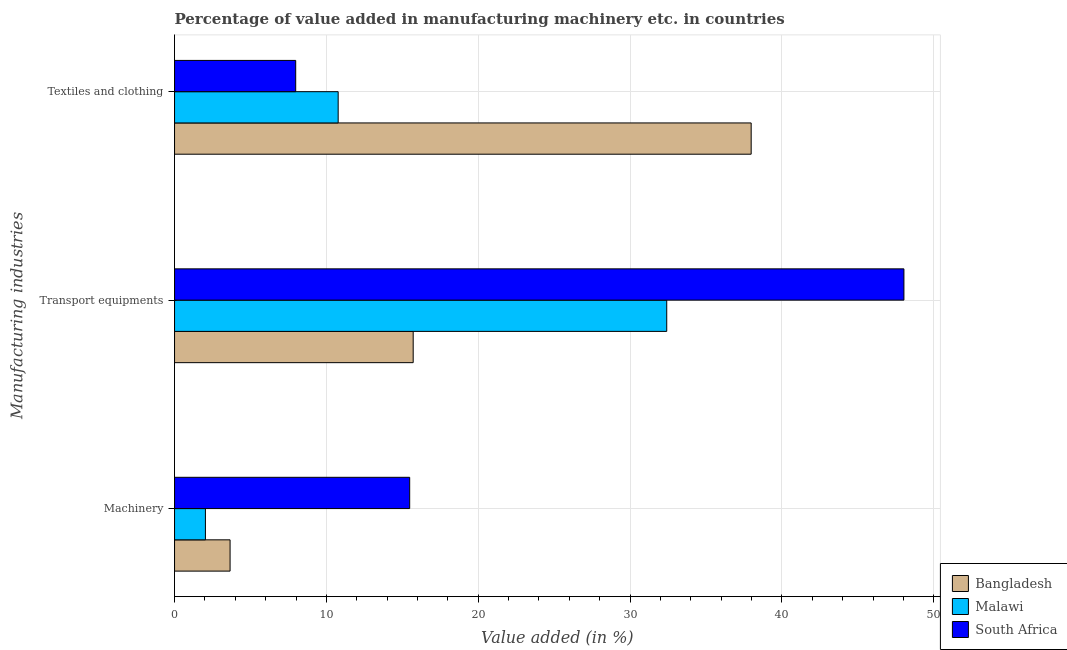Are the number of bars per tick equal to the number of legend labels?
Give a very brief answer. Yes. Are the number of bars on each tick of the Y-axis equal?
Keep it short and to the point. Yes. How many bars are there on the 3rd tick from the top?
Your answer should be compact. 3. How many bars are there on the 2nd tick from the bottom?
Your answer should be very brief. 3. What is the label of the 3rd group of bars from the top?
Your response must be concise. Machinery. What is the value added in manufacturing transport equipments in South Africa?
Make the answer very short. 48.04. Across all countries, what is the maximum value added in manufacturing machinery?
Your answer should be compact. 15.49. Across all countries, what is the minimum value added in manufacturing transport equipments?
Your answer should be compact. 15.72. In which country was the value added in manufacturing machinery maximum?
Your answer should be compact. South Africa. What is the total value added in manufacturing transport equipments in the graph?
Your answer should be compact. 96.17. What is the difference between the value added in manufacturing transport equipments in South Africa and that in Bangladesh?
Give a very brief answer. 32.32. What is the difference between the value added in manufacturing machinery in South Africa and the value added in manufacturing textile and clothing in Bangladesh?
Provide a succinct answer. -22.49. What is the average value added in manufacturing textile and clothing per country?
Make the answer very short. 18.91. What is the difference between the value added in manufacturing transport equipments and value added in manufacturing textile and clothing in Malawi?
Your response must be concise. 21.64. What is the ratio of the value added in manufacturing transport equipments in South Africa to that in Malawi?
Your answer should be compact. 1.48. Is the value added in manufacturing transport equipments in Bangladesh less than that in Malawi?
Make the answer very short. Yes. Is the difference between the value added in manufacturing machinery in Bangladesh and Malawi greater than the difference between the value added in manufacturing textile and clothing in Bangladesh and Malawi?
Give a very brief answer. No. What is the difference between the highest and the second highest value added in manufacturing machinery?
Ensure brevity in your answer.  11.83. What is the difference between the highest and the lowest value added in manufacturing transport equipments?
Provide a short and direct response. 32.32. Is the sum of the value added in manufacturing textile and clothing in South Africa and Malawi greater than the maximum value added in manufacturing transport equipments across all countries?
Ensure brevity in your answer.  No. What does the 1st bar from the top in Textiles and clothing represents?
Offer a very short reply. South Africa. What does the 2nd bar from the bottom in Textiles and clothing represents?
Offer a terse response. Malawi. Is it the case that in every country, the sum of the value added in manufacturing machinery and value added in manufacturing transport equipments is greater than the value added in manufacturing textile and clothing?
Provide a succinct answer. No. Are all the bars in the graph horizontal?
Keep it short and to the point. Yes. What is the difference between two consecutive major ticks on the X-axis?
Make the answer very short. 10. Are the values on the major ticks of X-axis written in scientific E-notation?
Provide a succinct answer. No. Does the graph contain any zero values?
Give a very brief answer. No. Does the graph contain grids?
Make the answer very short. Yes. Where does the legend appear in the graph?
Provide a short and direct response. Bottom right. How are the legend labels stacked?
Your answer should be compact. Vertical. What is the title of the graph?
Your answer should be compact. Percentage of value added in manufacturing machinery etc. in countries. Does "Algeria" appear as one of the legend labels in the graph?
Your answer should be compact. No. What is the label or title of the X-axis?
Make the answer very short. Value added (in %). What is the label or title of the Y-axis?
Ensure brevity in your answer.  Manufacturing industries. What is the Value added (in %) of Bangladesh in Machinery?
Offer a terse response. 3.66. What is the Value added (in %) of Malawi in Machinery?
Offer a terse response. 2.03. What is the Value added (in %) of South Africa in Machinery?
Ensure brevity in your answer.  15.49. What is the Value added (in %) in Bangladesh in Transport equipments?
Offer a very short reply. 15.72. What is the Value added (in %) of Malawi in Transport equipments?
Offer a very short reply. 32.42. What is the Value added (in %) of South Africa in Transport equipments?
Your answer should be very brief. 48.04. What is the Value added (in %) in Bangladesh in Textiles and clothing?
Keep it short and to the point. 37.98. What is the Value added (in %) of Malawi in Textiles and clothing?
Your response must be concise. 10.78. What is the Value added (in %) of South Africa in Textiles and clothing?
Make the answer very short. 7.98. Across all Manufacturing industries, what is the maximum Value added (in %) in Bangladesh?
Offer a terse response. 37.98. Across all Manufacturing industries, what is the maximum Value added (in %) in Malawi?
Your answer should be compact. 32.42. Across all Manufacturing industries, what is the maximum Value added (in %) of South Africa?
Your answer should be very brief. 48.04. Across all Manufacturing industries, what is the minimum Value added (in %) of Bangladesh?
Keep it short and to the point. 3.66. Across all Manufacturing industries, what is the minimum Value added (in %) in Malawi?
Provide a succinct answer. 2.03. Across all Manufacturing industries, what is the minimum Value added (in %) of South Africa?
Keep it short and to the point. 7.98. What is the total Value added (in %) of Bangladesh in the graph?
Offer a very short reply. 57.35. What is the total Value added (in %) in Malawi in the graph?
Give a very brief answer. 45.22. What is the total Value added (in %) in South Africa in the graph?
Keep it short and to the point. 71.5. What is the difference between the Value added (in %) in Bangladesh in Machinery and that in Transport equipments?
Provide a succinct answer. -12.06. What is the difference between the Value added (in %) of Malawi in Machinery and that in Transport equipments?
Offer a terse response. -30.38. What is the difference between the Value added (in %) of South Africa in Machinery and that in Transport equipments?
Ensure brevity in your answer.  -32.55. What is the difference between the Value added (in %) in Bangladesh in Machinery and that in Textiles and clothing?
Give a very brief answer. -34.32. What is the difference between the Value added (in %) in Malawi in Machinery and that in Textiles and clothing?
Make the answer very short. -8.74. What is the difference between the Value added (in %) in South Africa in Machinery and that in Textiles and clothing?
Your answer should be very brief. 7.51. What is the difference between the Value added (in %) of Bangladesh in Transport equipments and that in Textiles and clothing?
Provide a short and direct response. -22.26. What is the difference between the Value added (in %) in Malawi in Transport equipments and that in Textiles and clothing?
Provide a succinct answer. 21.64. What is the difference between the Value added (in %) of South Africa in Transport equipments and that in Textiles and clothing?
Your answer should be very brief. 40.06. What is the difference between the Value added (in %) of Bangladesh in Machinery and the Value added (in %) of Malawi in Transport equipments?
Your answer should be very brief. -28.76. What is the difference between the Value added (in %) of Bangladesh in Machinery and the Value added (in %) of South Africa in Transport equipments?
Your answer should be very brief. -44.38. What is the difference between the Value added (in %) of Malawi in Machinery and the Value added (in %) of South Africa in Transport equipments?
Offer a terse response. -46. What is the difference between the Value added (in %) of Bangladesh in Machinery and the Value added (in %) of Malawi in Textiles and clothing?
Offer a terse response. -7.12. What is the difference between the Value added (in %) of Bangladesh in Machinery and the Value added (in %) of South Africa in Textiles and clothing?
Make the answer very short. -4.32. What is the difference between the Value added (in %) in Malawi in Machinery and the Value added (in %) in South Africa in Textiles and clothing?
Your answer should be very brief. -5.95. What is the difference between the Value added (in %) in Bangladesh in Transport equipments and the Value added (in %) in Malawi in Textiles and clothing?
Offer a very short reply. 4.94. What is the difference between the Value added (in %) of Bangladesh in Transport equipments and the Value added (in %) of South Africa in Textiles and clothing?
Make the answer very short. 7.74. What is the difference between the Value added (in %) in Malawi in Transport equipments and the Value added (in %) in South Africa in Textiles and clothing?
Make the answer very short. 24.44. What is the average Value added (in %) of Bangladesh per Manufacturing industries?
Provide a succinct answer. 19.12. What is the average Value added (in %) in Malawi per Manufacturing industries?
Your answer should be very brief. 15.07. What is the average Value added (in %) in South Africa per Manufacturing industries?
Provide a short and direct response. 23.83. What is the difference between the Value added (in %) of Bangladesh and Value added (in %) of Malawi in Machinery?
Give a very brief answer. 1.62. What is the difference between the Value added (in %) of Bangladesh and Value added (in %) of South Africa in Machinery?
Make the answer very short. -11.83. What is the difference between the Value added (in %) of Malawi and Value added (in %) of South Africa in Machinery?
Your response must be concise. -13.45. What is the difference between the Value added (in %) in Bangladesh and Value added (in %) in Malawi in Transport equipments?
Ensure brevity in your answer.  -16.7. What is the difference between the Value added (in %) of Bangladesh and Value added (in %) of South Africa in Transport equipments?
Give a very brief answer. -32.32. What is the difference between the Value added (in %) of Malawi and Value added (in %) of South Africa in Transport equipments?
Your response must be concise. -15.62. What is the difference between the Value added (in %) of Bangladesh and Value added (in %) of Malawi in Textiles and clothing?
Provide a succinct answer. 27.2. What is the difference between the Value added (in %) of Bangladesh and Value added (in %) of South Africa in Textiles and clothing?
Your answer should be compact. 30. What is the difference between the Value added (in %) of Malawi and Value added (in %) of South Africa in Textiles and clothing?
Provide a short and direct response. 2.8. What is the ratio of the Value added (in %) in Bangladesh in Machinery to that in Transport equipments?
Keep it short and to the point. 0.23. What is the ratio of the Value added (in %) of Malawi in Machinery to that in Transport equipments?
Ensure brevity in your answer.  0.06. What is the ratio of the Value added (in %) in South Africa in Machinery to that in Transport equipments?
Provide a short and direct response. 0.32. What is the ratio of the Value added (in %) of Bangladesh in Machinery to that in Textiles and clothing?
Your answer should be compact. 0.1. What is the ratio of the Value added (in %) of Malawi in Machinery to that in Textiles and clothing?
Ensure brevity in your answer.  0.19. What is the ratio of the Value added (in %) in South Africa in Machinery to that in Textiles and clothing?
Provide a short and direct response. 1.94. What is the ratio of the Value added (in %) of Bangladesh in Transport equipments to that in Textiles and clothing?
Offer a terse response. 0.41. What is the ratio of the Value added (in %) of Malawi in Transport equipments to that in Textiles and clothing?
Your response must be concise. 3.01. What is the ratio of the Value added (in %) in South Africa in Transport equipments to that in Textiles and clothing?
Your answer should be very brief. 6.02. What is the difference between the highest and the second highest Value added (in %) of Bangladesh?
Provide a succinct answer. 22.26. What is the difference between the highest and the second highest Value added (in %) in Malawi?
Keep it short and to the point. 21.64. What is the difference between the highest and the second highest Value added (in %) in South Africa?
Your answer should be compact. 32.55. What is the difference between the highest and the lowest Value added (in %) of Bangladesh?
Make the answer very short. 34.32. What is the difference between the highest and the lowest Value added (in %) of Malawi?
Offer a very short reply. 30.38. What is the difference between the highest and the lowest Value added (in %) of South Africa?
Ensure brevity in your answer.  40.06. 